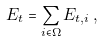<formula> <loc_0><loc_0><loc_500><loc_500>E _ { t } = \sum _ { i \in \Omega } { E _ { t , i } } \, ,</formula> 